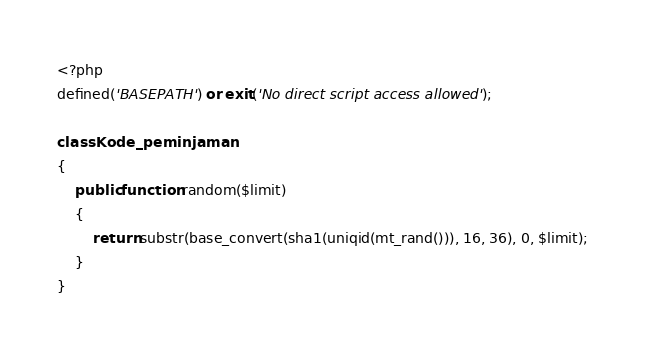<code> <loc_0><loc_0><loc_500><loc_500><_PHP_><?php
defined('BASEPATH') or exit('No direct script access allowed');

class Kode_peminjaman
{
    public function random($limit)
    {
        return substr(base_convert(sha1(uniqid(mt_rand())), 16, 36), 0, $limit);
    }
}
</code> 